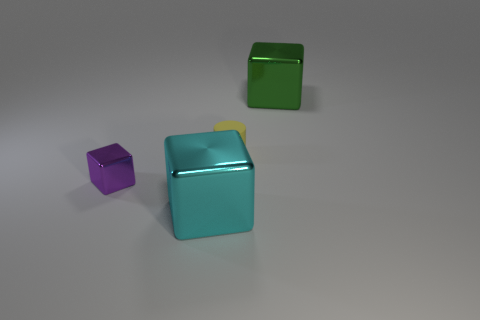How does the lighting affect the appearance of the objects? The lighting in the image casts soft shadows to the right side of the objects, suggesting a light source to the left. This gentle lighting accentuates the metallic sheen of the cubes and the matte finish of the cylinder, highlighting their textures and the reflective nature of the metallic surfaces.  I see a yellow detail on one of the cubes, what does it look like? The yellow detail on the turquoise cube appears to be a small square patch or sticker. It's affixed to the top surface of the cube, adding a pop of contrasting color to the otherwise monochromatic turquoise cube. 